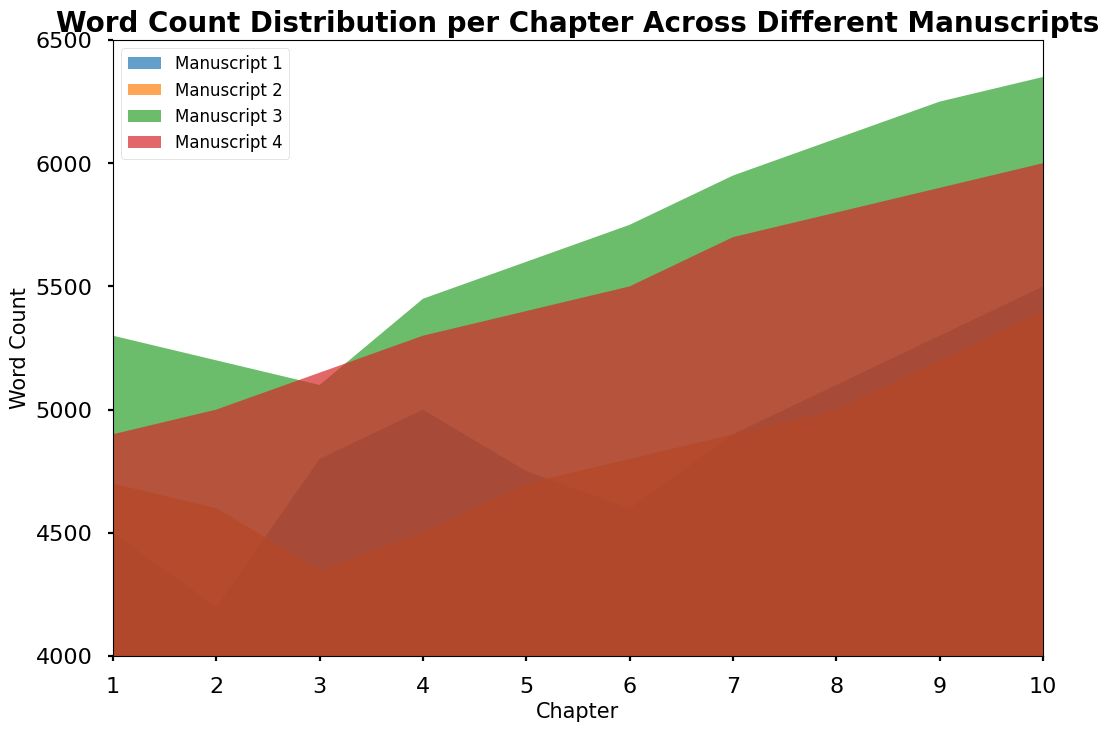how do the word counts in manuscript 1 and manuscript 3 compare in chapter 5? identify the word counts for each manuscript in chapter 5, manuscript 1 has 4750 words and manuscript 3 has 5600 words, compare the values
Answer: the word count is higher in manuscript 3 does the word count increase steadily from chapter 1 to chapter 10 in manuscript 4? identify the pattern of word counts in manuscript 4 across chapters 1 to 10, the word counts are 4900, 5000, 5150, 5300, 5400, 5500, 5700, 5800, 5900, 6000, the values consistently increase
Answer: yes which manuscript has the highest word count in chapter 7? identify the word counts for chapter 7 across all manuscripts: manuscript 1 has 4900, manuscript 2 has 4900, manuscript 3 has 5950, and manuscript 4 has 5700, manuscript 3 has the highest value
Answer: manuscript 3 is there any point where manuscript 2 and manuscript 4 have the same word count? compare word counts across all chapters for manuscript 2 and manuscript 4, identify chapter 1 having 4700 and 4900, chapter 2 having 4600 and 5000, and continue similarly, no chapters have the same word counts
Answer: no what is the average word count of chapter 3 across all manuscripts? identify and sum the word counts for chapter 3 in all manuscripts: 4800, 4350, 5100, 5150; the total is (4800 + 4350 + 5100 + 5150) = 19400, thus the average is 19400/4 = 4850
Answer: 4850 